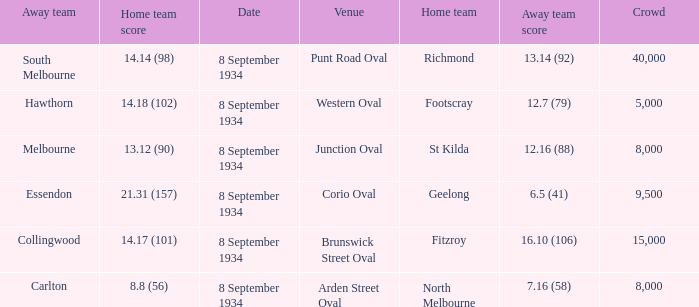When Melbourne was the Away team, what was their score? 12.16 (88). 